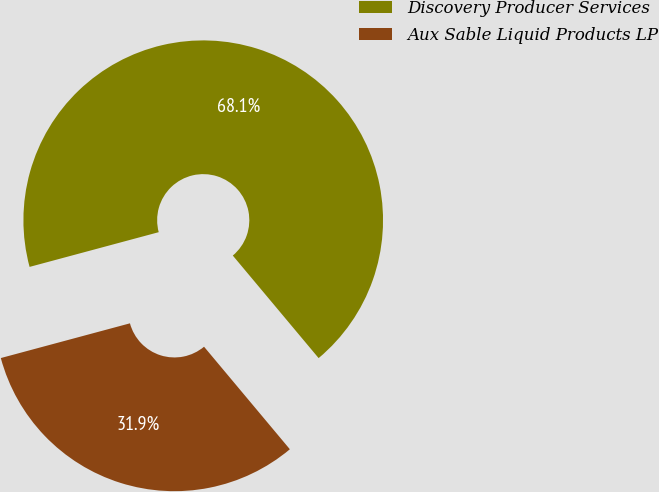Convert chart. <chart><loc_0><loc_0><loc_500><loc_500><pie_chart><fcel>Discovery Producer Services<fcel>Aux Sable Liquid Products LP<nl><fcel>68.09%<fcel>31.91%<nl></chart> 